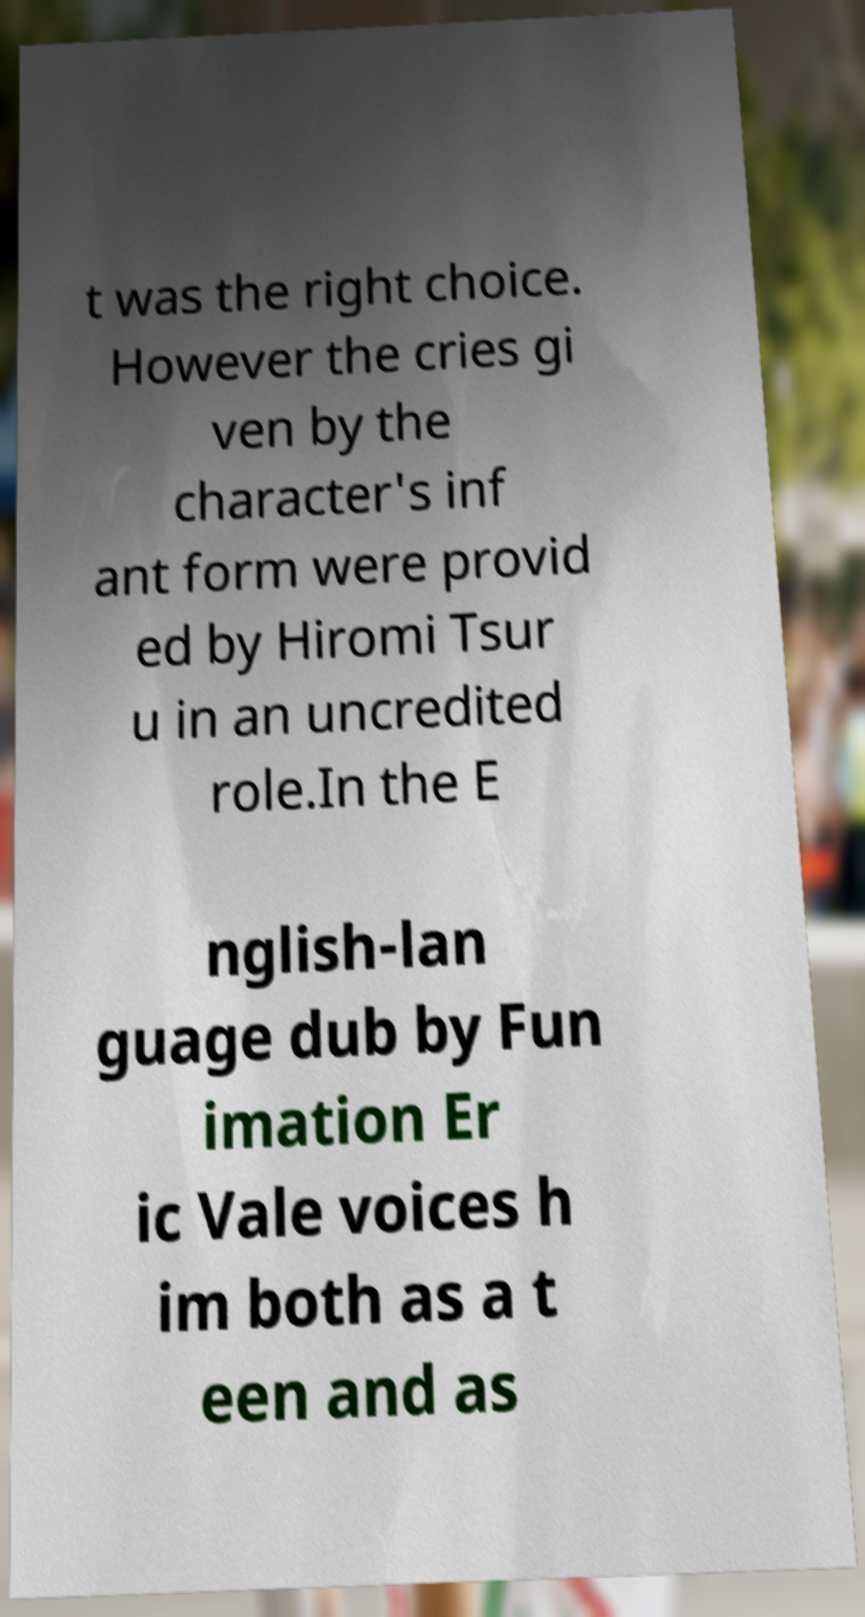I need the written content from this picture converted into text. Can you do that? t was the right choice. However the cries gi ven by the character's inf ant form were provid ed by Hiromi Tsur u in an uncredited role.In the E nglish-lan guage dub by Fun imation Er ic Vale voices h im both as a t een and as 